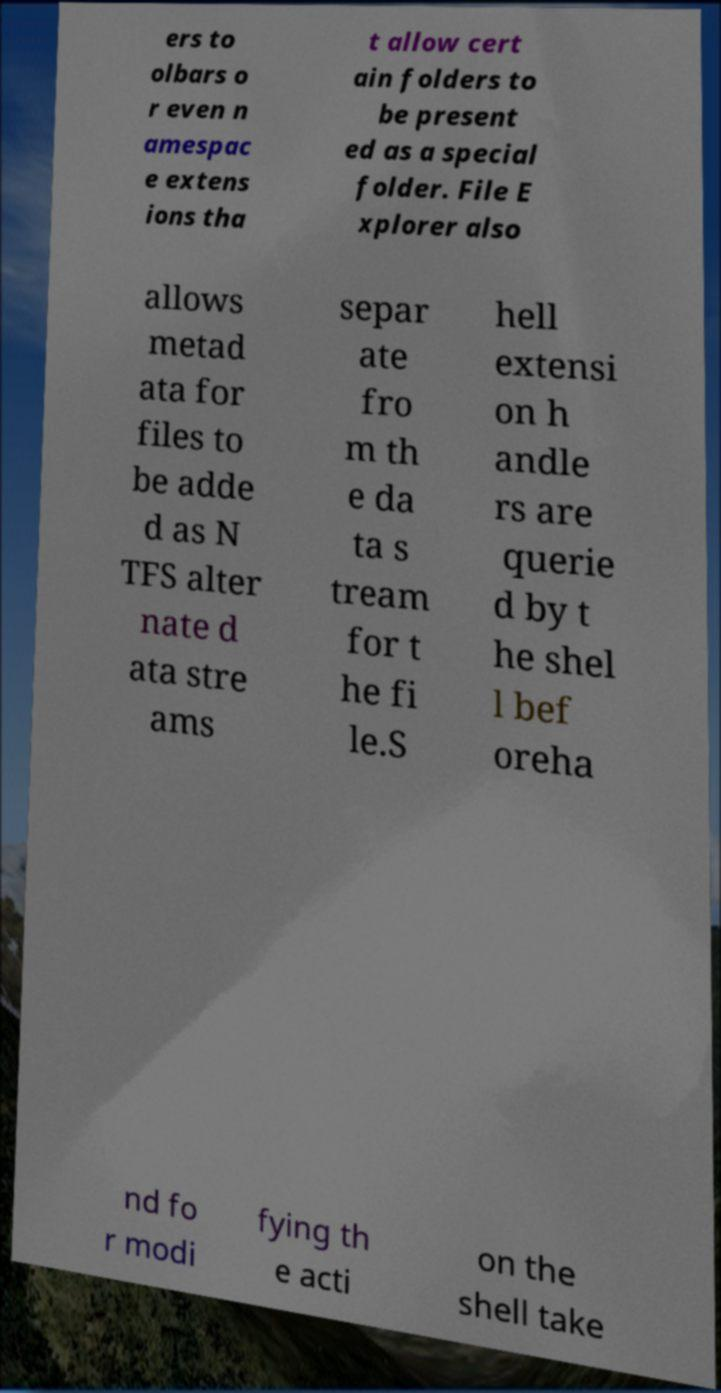Can you read and provide the text displayed in the image?This photo seems to have some interesting text. Can you extract and type it out for me? ers to olbars o r even n amespac e extens ions tha t allow cert ain folders to be present ed as a special folder. File E xplorer also allows metad ata for files to be adde d as N TFS alter nate d ata stre ams separ ate fro m th e da ta s tream for t he fi le.S hell extensi on h andle rs are querie d by t he shel l bef oreha nd fo r modi fying th e acti on the shell take 